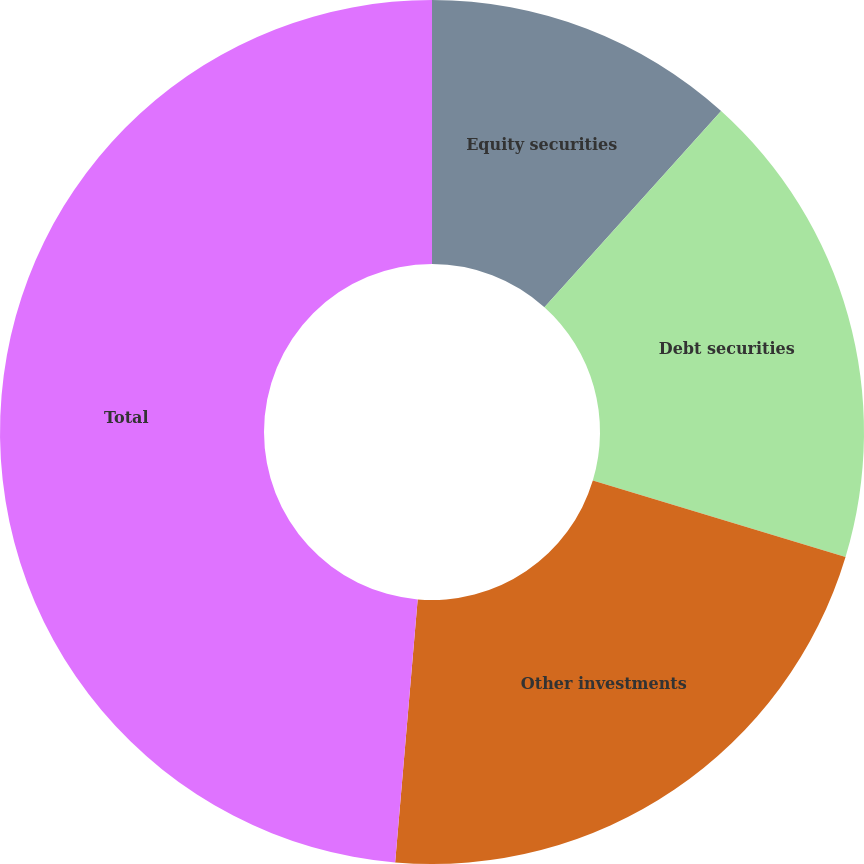Convert chart. <chart><loc_0><loc_0><loc_500><loc_500><pie_chart><fcel>Equity securities<fcel>Debt securities<fcel>Other investments<fcel>Total<nl><fcel>11.67%<fcel>18.0%<fcel>21.69%<fcel>48.64%<nl></chart> 